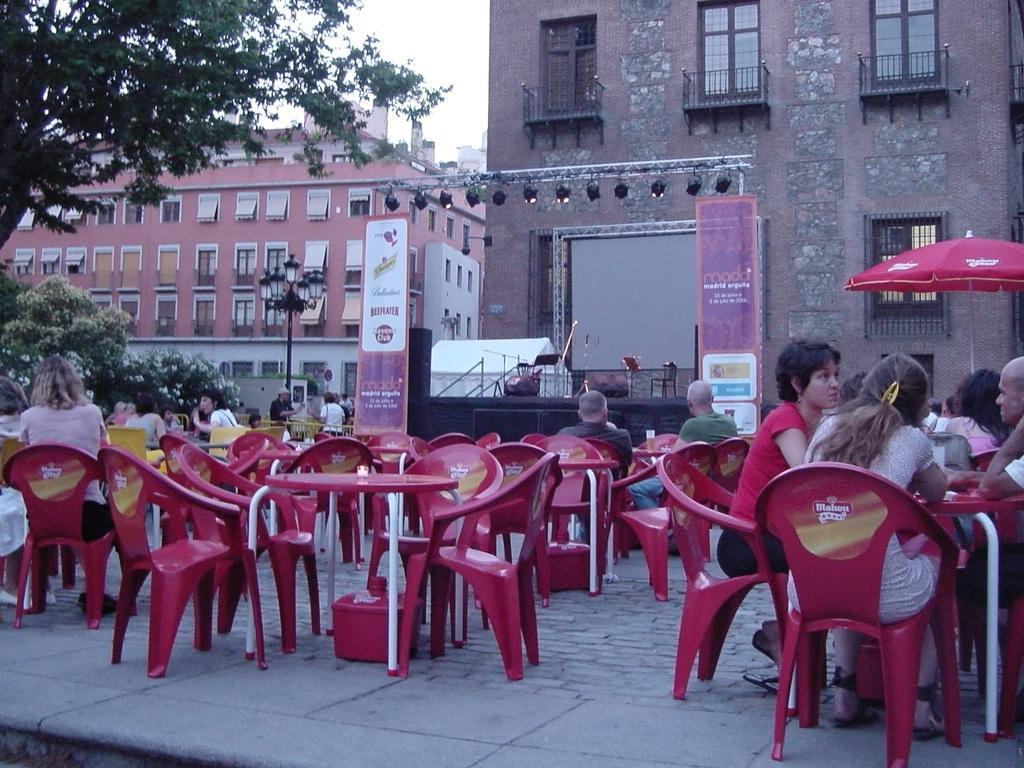Can you describe this image briefly? Group of people sitting on the chairs. We can see tables and chairs,banners,stage,trees,lights with pole,buildings,sky 